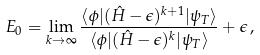Convert formula to latex. <formula><loc_0><loc_0><loc_500><loc_500>E _ { 0 } = \lim _ { k \rightarrow \infty } \frac { \langle \phi | ( \hat { H } - \epsilon ) ^ { k + 1 } | \psi _ { T } \rangle } { \langle \phi | ( \hat { H } - \epsilon ) ^ { k } | \psi _ { T } \rangle } + \epsilon \, ,</formula> 